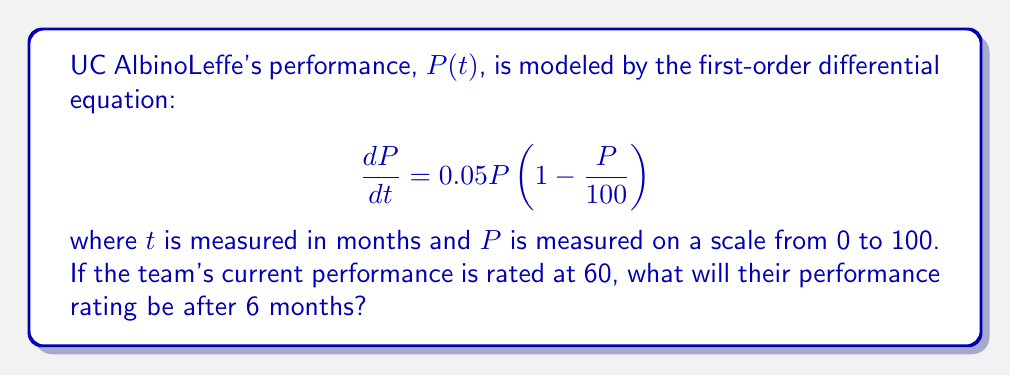Give your solution to this math problem. To solve this problem, we need to use the separation of variables method and integrate both sides of the equation.

1) Rewrite the differential equation:
   $$\frac{dP}{P(1 - \frac{P}{100})} = 0.05dt$$

2) Integrate both sides:
   $$\int \frac{dP}{P(1 - \frac{P}{100})} = \int 0.05dt$$

3) The left side can be integrated using partial fractions:
   $$\int \frac{dP}{P(1 - \frac{P}{100})} = -100[\frac{\ln|P|}{100} + \ln|100-P|] + C$$

4) The right side integrates to:
   $$\int 0.05dt = 0.05t + C$$

5) Combining these results:
   $$-100[\frac{\ln|P|}{100} + \ln|100-P|] = 0.05t + C$$

6) Simplify and solve for $P$:
   $$\ln|\frac{100-P}{P}| = -0.05t - C$$
   $$\frac{100-P}{P} = Ke^{-0.05t}$$
   $$P = \frac{100}{1 + Ke^{-0.05t}}$$

7) Use the initial condition $P(0) = 60$ to find $K$:
   $$60 = \frac{100}{1 + K}$$
   $$K = \frac{2}{3}$$

8) The final solution is:
   $$P(t) = \frac{100}{1 + \frac{2}{3}e^{-0.05t}}$$

9) To find $P(6)$, substitute $t = 6$:
   $$P(6) = \frac{100}{1 + \frac{2}{3}e^{-0.05(6)}} \approx 66.76$$
Answer: After 6 months, UC AlbinoLeffe's performance rating will be approximately 66.76. 